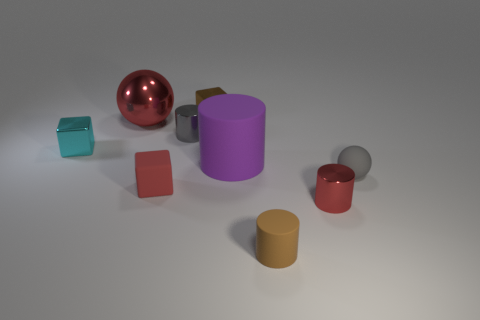Subtract all brown rubber cylinders. How many cylinders are left? 3 Add 1 red spheres. How many objects exist? 10 Subtract all cylinders. How many objects are left? 5 Subtract all red cubes. How many cubes are left? 2 Subtract 2 cylinders. How many cylinders are left? 2 Add 9 brown cylinders. How many brown cylinders are left? 10 Add 4 purple shiny cubes. How many purple shiny cubes exist? 4 Subtract 0 green blocks. How many objects are left? 9 Subtract all blue cubes. Subtract all red cylinders. How many cubes are left? 3 Subtract all brown matte cylinders. Subtract all tiny red matte blocks. How many objects are left? 7 